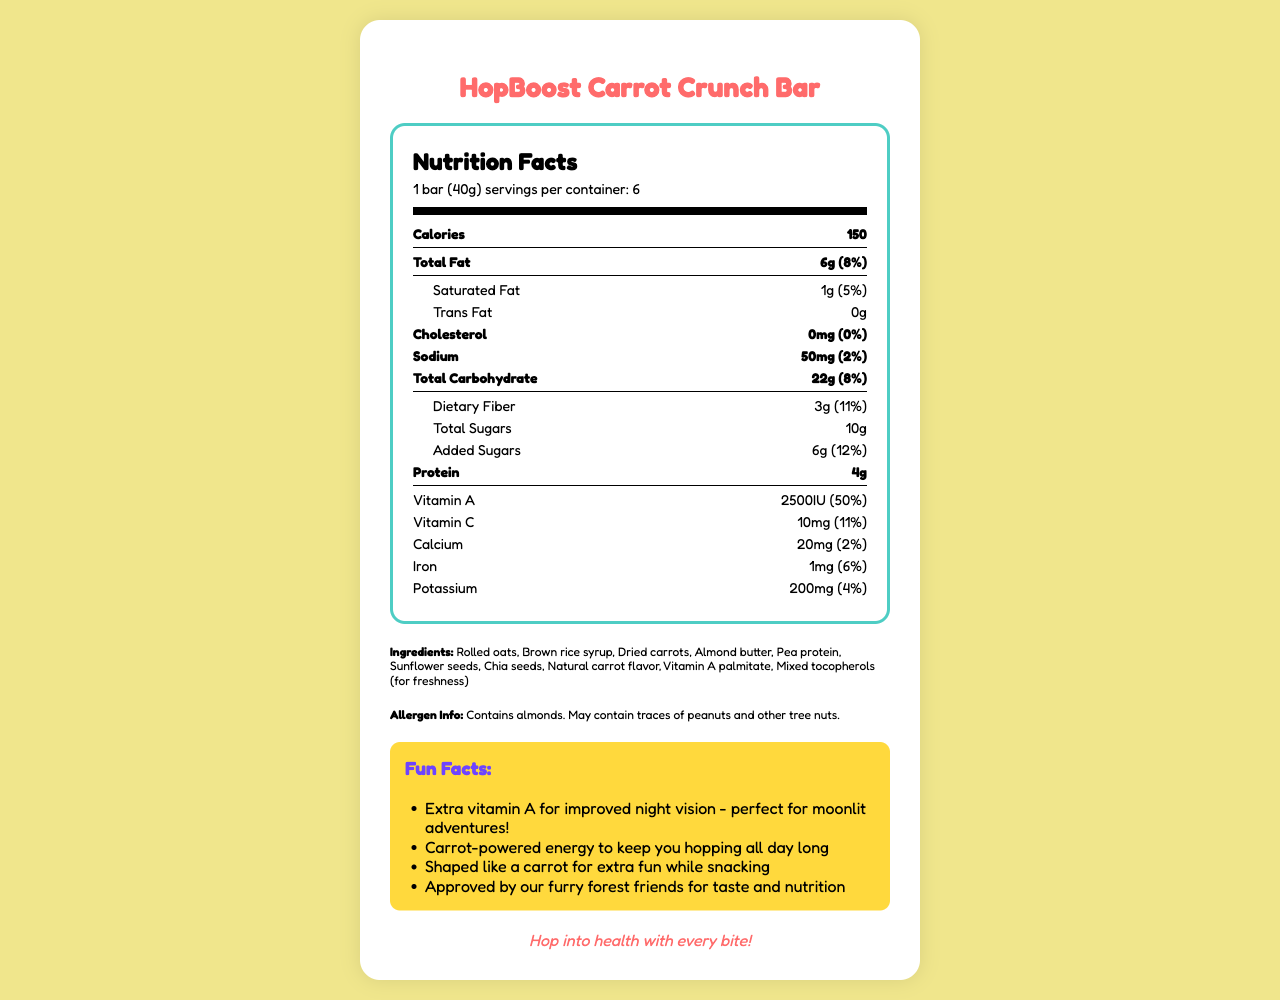what is the serving size of HopBoost Carrot Crunch Bar? The serving size is mentioned in the Nutrition Facts section, "serving size: 1 bar (40g)".
Answer: 1 bar (40g) how many calories are there per serving? The calories per serving are listed under the Nutrition Facts, "Calories: 150".
Answer: 150 calories what is the total fat content per serving and its daily value percentage? The total fat content and its daily value percentage are given directly in the Nutrition Facts, "Total Fat: 6g (8%)".
Answer: 6g (8%) list three major ingredients of HopBoost Carrot Crunch Bar. The ingredients are listed under the Ingredients section. The first three are "Rolled oats, Brown rice syrup, Dried carrots".
Answer: Rolled oats, Brown rice syrup, Dried carrots does this product contain any allergens? The Allergen Info section states "Contains almonds. May contain traces of peanuts and other tree nuts."
Answer: Yes how much vitamin A is in each serving and what percentage of the daily value does it cover? The amount of Vitamin A and its daily value percentage are listed in the Nutrition Facts, "Vitamin A: 2500IU (50%)".
Answer: 2500IU (50%) what is the cholesterol content per serving? The cholesterol content per serving is listed as "Cholesterol: 0mg".
Answer: 0mg which company manufactures the HopBoost Carrot Crunch Bar? The manufacturer is listed at the bottom of the document.
Answer: Woodland Wonders Nutrition Co. what are some fun facts mentioned about the product? The fun facts are listed under the Fun Facts section.
Answer: 1. Extra vitamin A for improved night vision - perfect for moonlit adventures!
2. Carrot-powered energy to keep you hopping all day long
3. Shaped like a carrot for extra fun while snacking
4. Approved by our furry forest friends for taste and nutrition how many servings are there in one container? The number of servings per container is given in the serving info, "servings per container: 6".
Answer: 6 does this product contain any sugar? The Nutrition Facts list both total sugars (10g) and added sugars (6g).
Answer: Yes is the document's slogan related to health benefits? The slogan "Hop into health with every bite!" indicates a health benefit.
Answer: Yes what additional benefit does the vitamin A in the product provide? One fun fact mentions, "Extra vitamin A for improved night vision - perfect for moonlit adventures!"
Answer: Improved night vision compute the total calorie count if you consume 3 bars of HopBoost Carrot Crunch Bar. Each bar provides 150 calories. Therefore, consuming 3 bars would total 450 calories (150 x 3).
Answer: 450 calories what kind of seeds are included in the ingredients? The Ingredients section lists both "Sunflower seeds" and "Chia seeds".
Answer: Sunflower seeds, Chia seeds can consuming this product alone provide the recommended daily intake of vitamins and minerals? The daily value percentages in the Nutrition Facts indicate that the product does not provide 100% of the recommended daily intake for any single vitamin or mineral.
Answer: No. summarize the main idea of the document. The comprehensive layout covers nutritional values per serving, ingredients, allergen information, and fun promotional statements about the product, manufactured by Woodland Wonders Nutrition Co.
Answer: The document provides detailed nutritional information about the HopBoost Carrot Crunch Bar, which is an energy snack bar designed for health-conscious consumers. It highlights its key ingredients, allergen information, storage instructions, and fun facts about the product, emphasizing its vitamin A content for improved night vision and carrot flavor for energy. how many grams of dietary fiber does each serving contain? The dietary fiber content per serving is listed as "Dietary Fiber: 3g".
Answer: 3g who approved the HopBoost Carrot Crunch Bar for taste and nutrition? The document mentions that it is "Approved by our furry forest friends," but it does not specify who exactly these friends are, making it unclear.
Answer: I don't know 